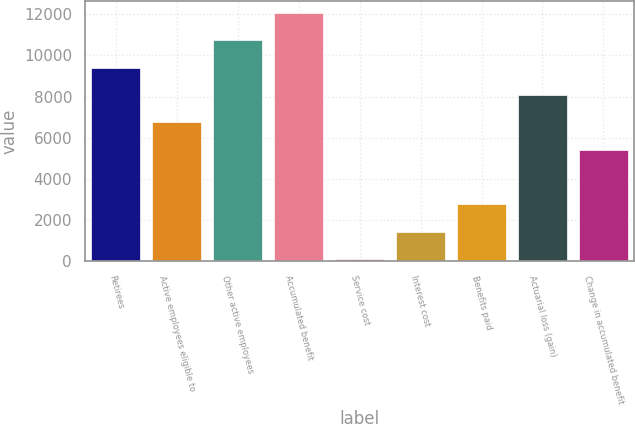<chart> <loc_0><loc_0><loc_500><loc_500><bar_chart><fcel>Retirees<fcel>Active employees eligible to<fcel>Other active employees<fcel>Accumulated benefit<fcel>Service cost<fcel>Interest cost<fcel>Benefits paid<fcel>Actuarial loss (gain)<fcel>Change in accumulated benefit<nl><fcel>9409<fcel>6751<fcel>10738<fcel>12067<fcel>106<fcel>1435<fcel>2764<fcel>8080<fcel>5422<nl></chart> 